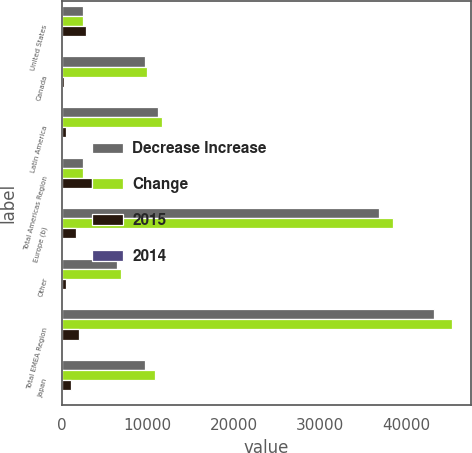Convert chart. <chart><loc_0><loc_0><loc_500><loc_500><stacked_bar_chart><ecel><fcel>United States<fcel>Canada<fcel>Latin America<fcel>Total Americas Region<fcel>Europe (b)<fcel>Other<fcel>Total EMEA Region<fcel>Japan<nl><fcel>Decrease Increase<fcel>2437.5<fcel>9669<fcel>11173<fcel>2437.5<fcel>36894<fcel>6393<fcel>43287<fcel>9700<nl><fcel>Change<fcel>2437.5<fcel>9871<fcel>11652<fcel>2437.5<fcel>38491<fcel>6832<fcel>45323<fcel>10775<nl><fcel>2015<fcel>2839<fcel>202<fcel>479<fcel>3520<fcel>1597<fcel>439<fcel>2036<fcel>1075<nl><fcel>2014<fcel>1.7<fcel>2<fcel>4.1<fcel>1.8<fcel>4.1<fcel>6.4<fcel>4.5<fcel>10<nl></chart> 